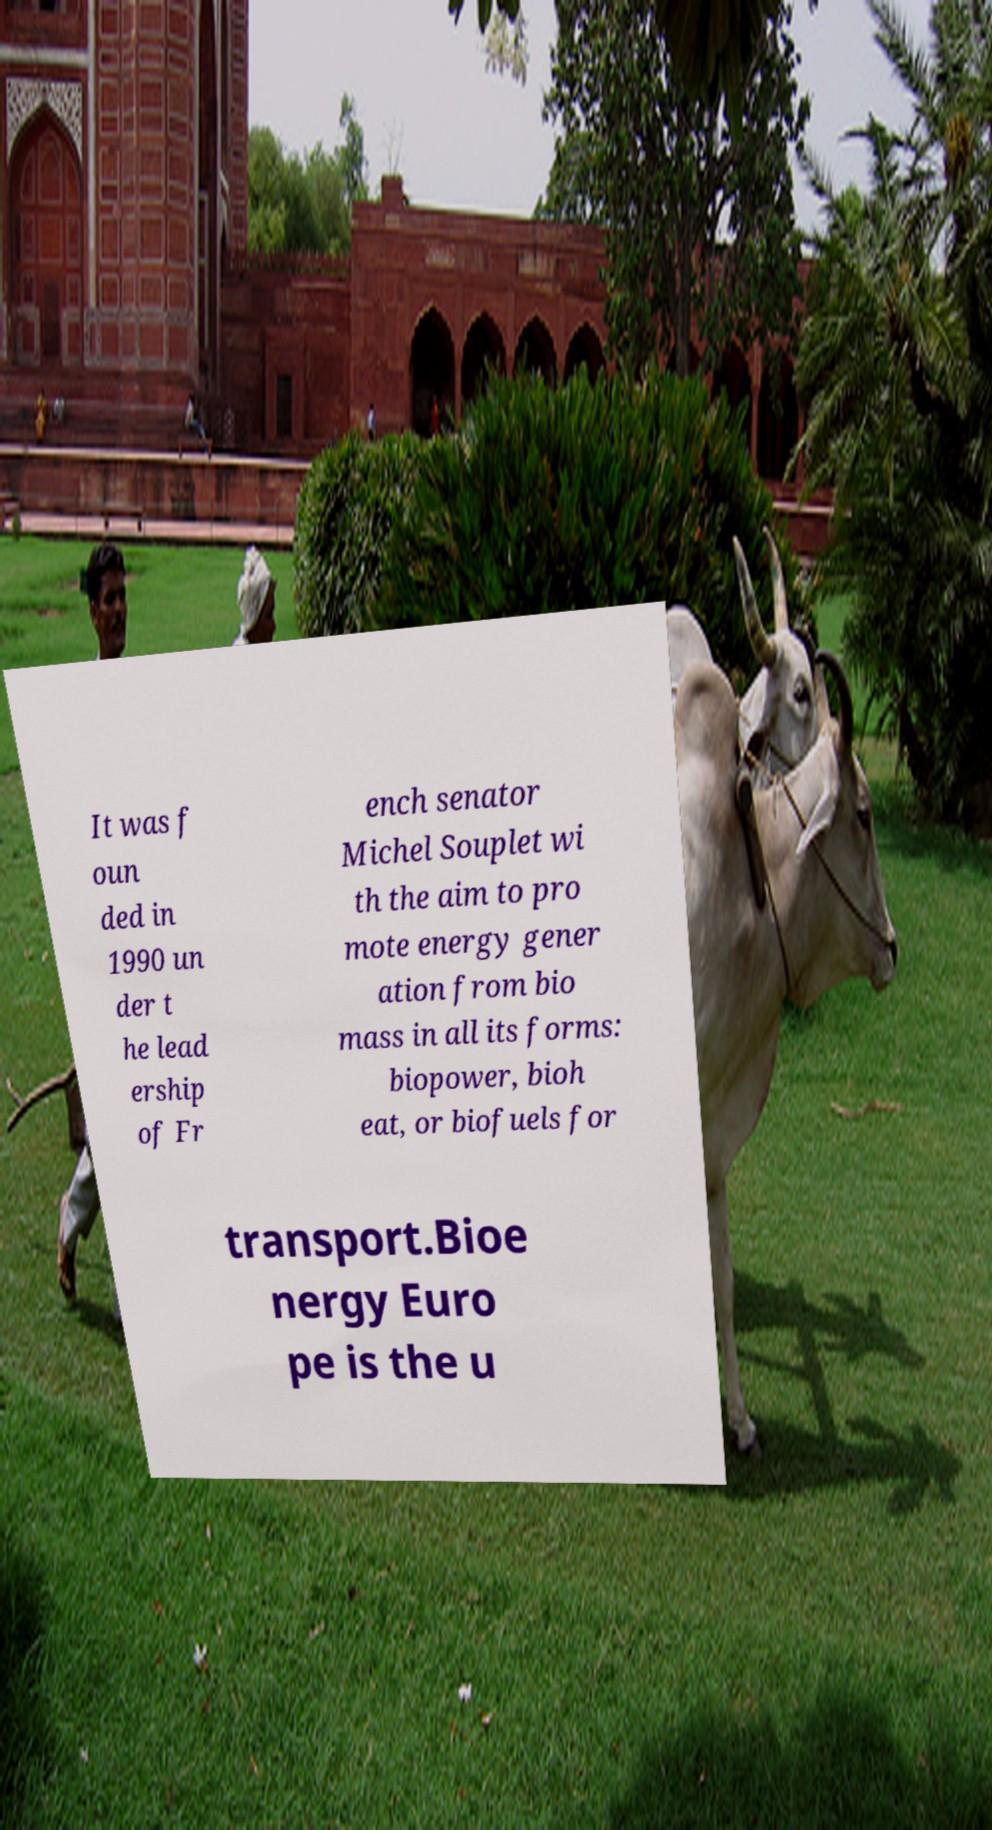Please identify and transcribe the text found in this image. It was f oun ded in 1990 un der t he lead ership of Fr ench senator Michel Souplet wi th the aim to pro mote energy gener ation from bio mass in all its forms: biopower, bioh eat, or biofuels for transport.Bioe nergy Euro pe is the u 